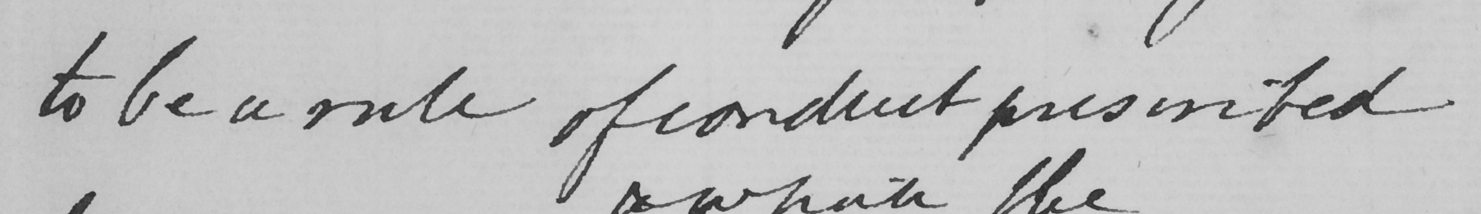What text is written in this handwritten line? to be a rule of conduct presented 